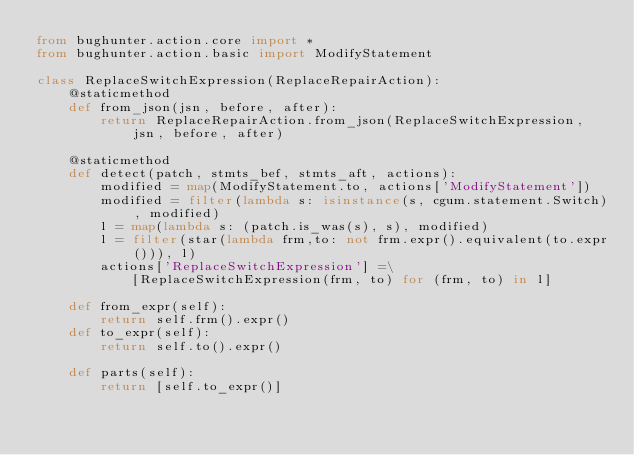<code> <loc_0><loc_0><loc_500><loc_500><_Python_>from bughunter.action.core import *
from bughunter.action.basic import ModifyStatement

class ReplaceSwitchExpression(ReplaceRepairAction):
    @staticmethod
    def from_json(jsn, before, after):
        return ReplaceRepairAction.from_json(ReplaceSwitchExpression, jsn, before, after)

    @staticmethod
    def detect(patch, stmts_bef, stmts_aft, actions):
        modified = map(ModifyStatement.to, actions['ModifyStatement'])
        modified = filter(lambda s: isinstance(s, cgum.statement.Switch), modified)
        l = map(lambda s: (patch.is_was(s), s), modified)
        l = filter(star(lambda frm,to: not frm.expr().equivalent(to.expr())), l)
        actions['ReplaceSwitchExpression'] =\
            [ReplaceSwitchExpression(frm, to) for (frm, to) in l]

    def from_expr(self):
        return self.frm().expr()
    def to_expr(self):
        return self.to().expr()

    def parts(self):
        return [self.to_expr()]
</code> 